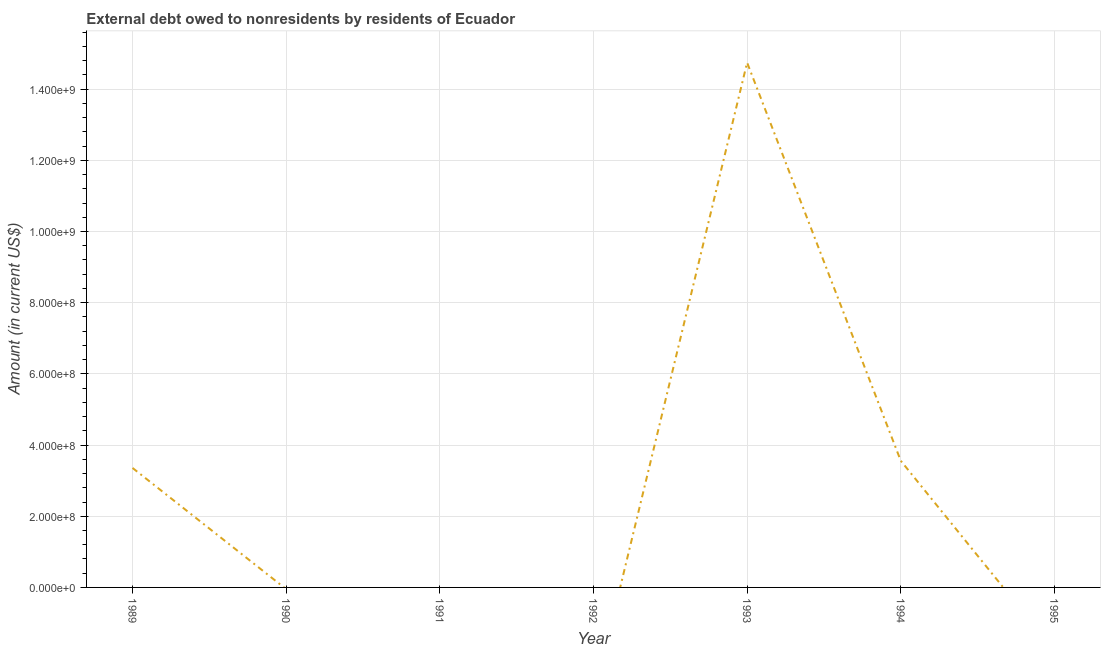What is the debt in 1989?
Offer a very short reply. 3.36e+08. Across all years, what is the maximum debt?
Give a very brief answer. 1.47e+09. Across all years, what is the minimum debt?
Keep it short and to the point. 0. What is the sum of the debt?
Give a very brief answer. 2.17e+09. What is the difference between the debt in 1989 and 1994?
Your answer should be very brief. -2.02e+07. What is the average debt per year?
Make the answer very short. 3.09e+08. What is the median debt?
Keep it short and to the point. 0. In how many years, is the debt greater than 880000000 US$?
Make the answer very short. 1. What is the ratio of the debt in 1993 to that in 1994?
Offer a very short reply. 4.14. Is the difference between the debt in 1989 and 1993 greater than the difference between any two years?
Keep it short and to the point. No. What is the difference between the highest and the second highest debt?
Provide a succinct answer. 1.12e+09. What is the difference between the highest and the lowest debt?
Provide a succinct answer. 1.47e+09. How many lines are there?
Your answer should be compact. 1. How many years are there in the graph?
Provide a short and direct response. 7. Does the graph contain grids?
Offer a very short reply. Yes. What is the title of the graph?
Keep it short and to the point. External debt owed to nonresidents by residents of Ecuador. What is the label or title of the Y-axis?
Your response must be concise. Amount (in current US$). What is the Amount (in current US$) in 1989?
Provide a succinct answer. 3.36e+08. What is the Amount (in current US$) in 1990?
Offer a very short reply. 0. What is the Amount (in current US$) in 1993?
Make the answer very short. 1.47e+09. What is the Amount (in current US$) of 1994?
Your answer should be compact. 3.56e+08. What is the Amount (in current US$) of 1995?
Give a very brief answer. 0. What is the difference between the Amount (in current US$) in 1989 and 1993?
Your answer should be very brief. -1.14e+09. What is the difference between the Amount (in current US$) in 1989 and 1994?
Your answer should be very brief. -2.02e+07. What is the difference between the Amount (in current US$) in 1993 and 1994?
Provide a succinct answer. 1.12e+09. What is the ratio of the Amount (in current US$) in 1989 to that in 1993?
Your answer should be compact. 0.23. What is the ratio of the Amount (in current US$) in 1989 to that in 1994?
Keep it short and to the point. 0.94. What is the ratio of the Amount (in current US$) in 1993 to that in 1994?
Keep it short and to the point. 4.14. 